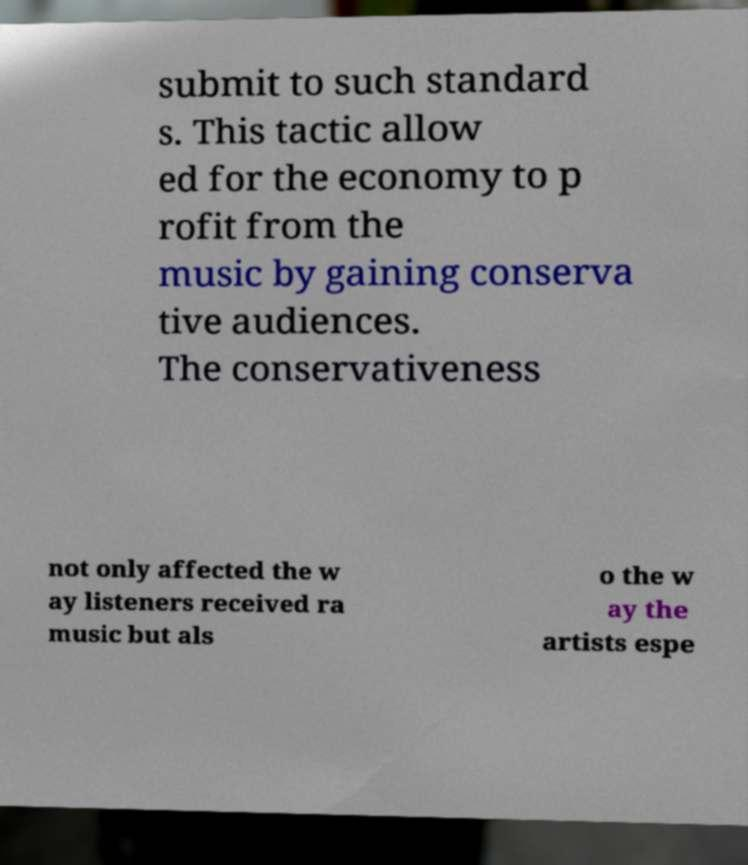I need the written content from this picture converted into text. Can you do that? submit to such standard s. This tactic allow ed for the economy to p rofit from the music by gaining conserva tive audiences. The conservativeness not only affected the w ay listeners received ra music but als o the w ay the artists espe 